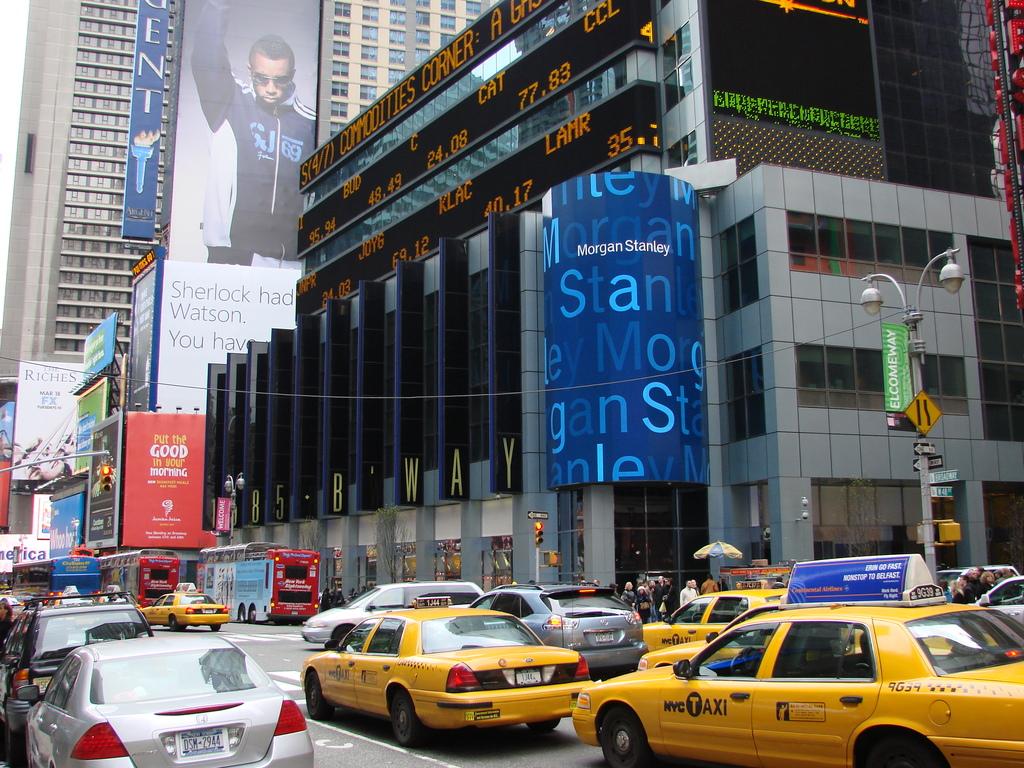What is the name of the one of the stocks on the scrolling marque?
Provide a short and direct response. Lamr. What investment bank is shown on the blue sign?
Offer a very short reply. Morgan stanley. 